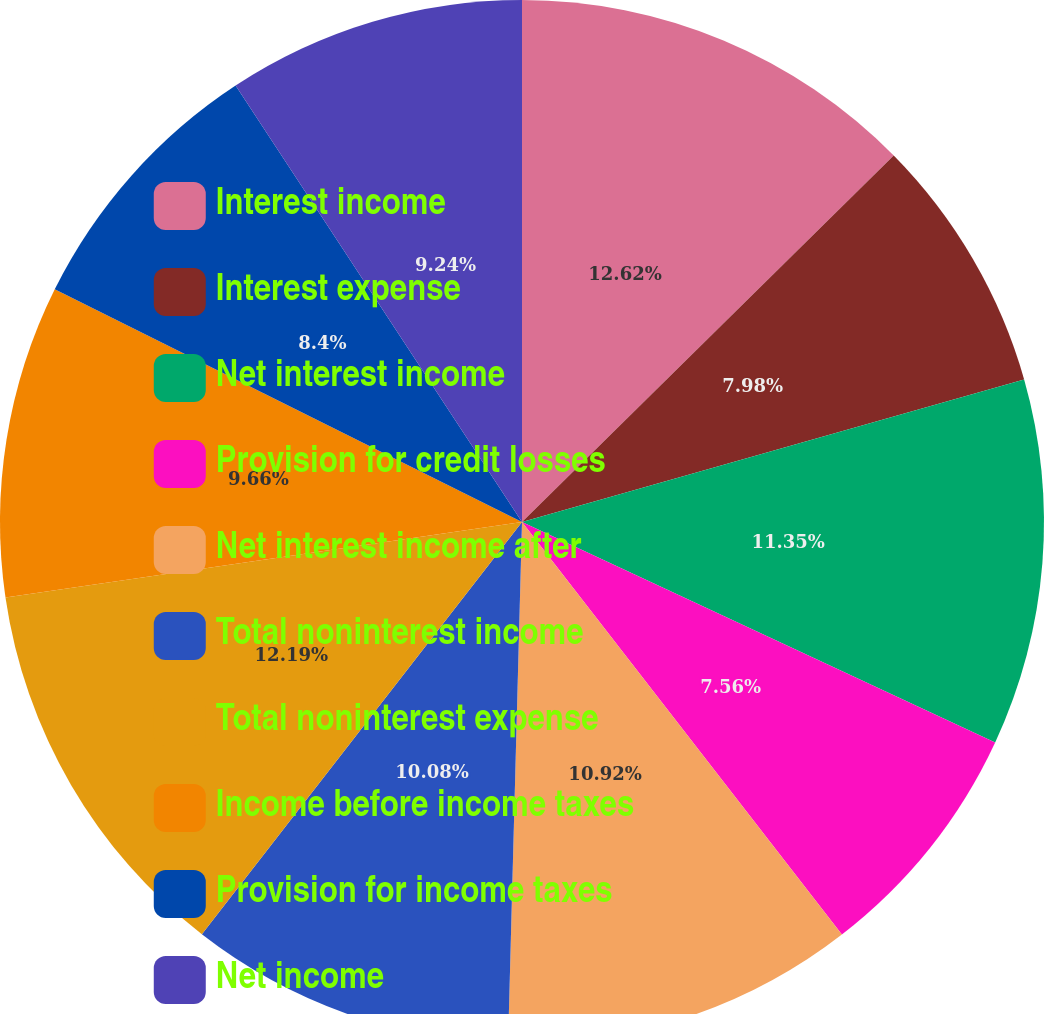Convert chart to OTSL. <chart><loc_0><loc_0><loc_500><loc_500><pie_chart><fcel>Interest income<fcel>Interest expense<fcel>Net interest income<fcel>Provision for credit losses<fcel>Net interest income after<fcel>Total noninterest income<fcel>Total noninterest expense<fcel>Income before income taxes<fcel>Provision for income taxes<fcel>Net income<nl><fcel>12.61%<fcel>7.98%<fcel>11.34%<fcel>7.56%<fcel>10.92%<fcel>10.08%<fcel>12.18%<fcel>9.66%<fcel>8.4%<fcel>9.24%<nl></chart> 